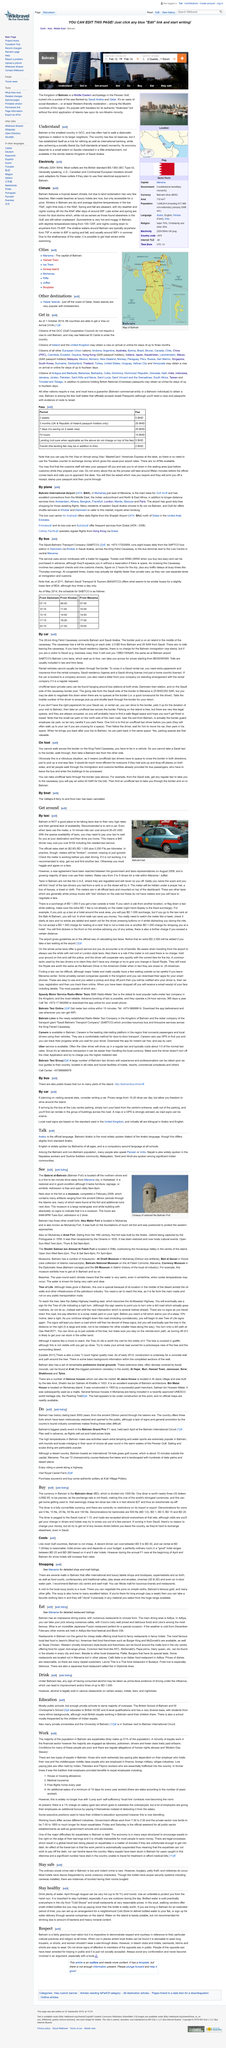Outline some significant characteristics in this image. The Bahrain Grand Prix is held annually in the month of April. The Bahrain Fort is located next to a museum. It would be more efficient to have pick-up and drop-off places on both sides of the border, allowing people to walk through existing immigration and customs facilities for bus passengers who must exit the bus and enter the buildings for processing. In Bahrain, one can engage in various activities such as sailing and scuba diving to experience the rich marine life and stunning underwater scenery. The electricity outlet in Bahrain is officially 220V 50Hz, which is the British standard BS-1363 (IEC  Type G). 